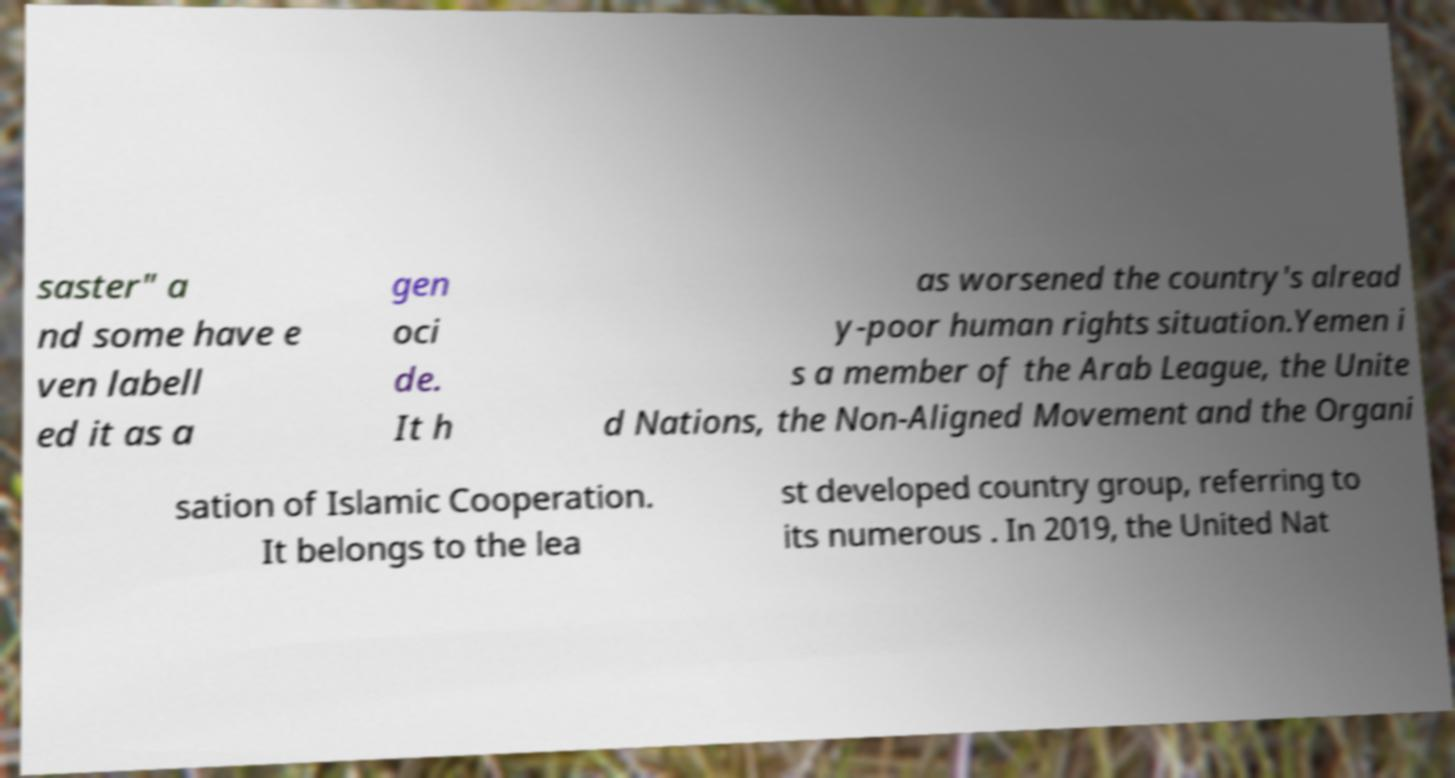There's text embedded in this image that I need extracted. Can you transcribe it verbatim? saster" a nd some have e ven labell ed it as a gen oci de. It h as worsened the country's alread y-poor human rights situation.Yemen i s a member of the Arab League, the Unite d Nations, the Non-Aligned Movement and the Organi sation of Islamic Cooperation. It belongs to the lea st developed country group, referring to its numerous . In 2019, the United Nat 